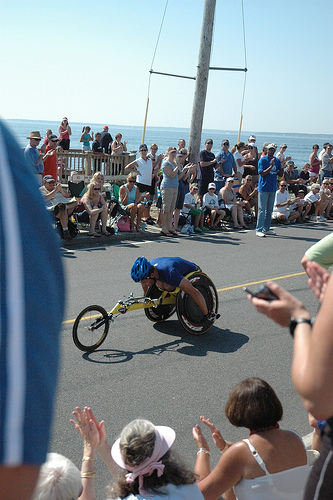<image>
Is there a woman behind the bicycle? Yes. From this viewpoint, the woman is positioned behind the bicycle, with the bicycle partially or fully occluding the woman. 